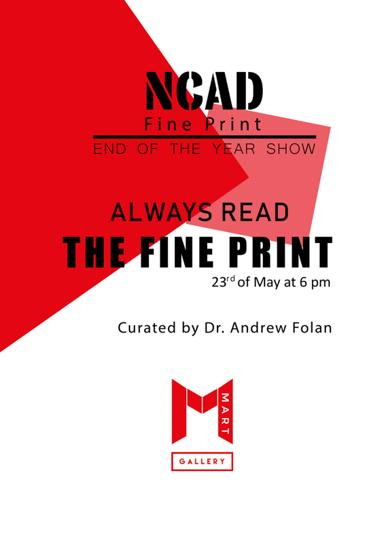Why might 'Always Read the Fine Print' be an intriguing title for this show? The title 'Always Read the Fine Print' cleverly suggests that the artworks displayed might contain subtle details or hidden messages, urging viewers to look more closely and appreciate the finer nuances of the print art. 